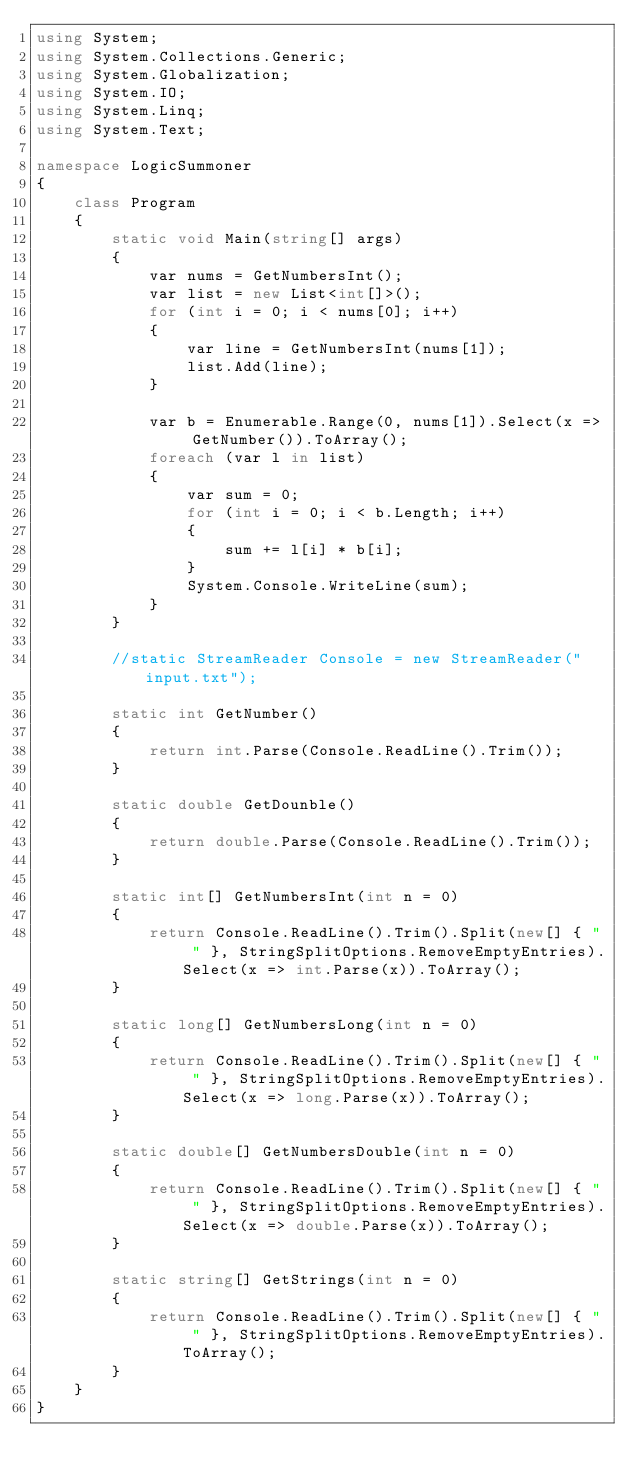Convert code to text. <code><loc_0><loc_0><loc_500><loc_500><_C#_>using System;
using System.Collections.Generic;
using System.Globalization;
using System.IO;
using System.Linq;
using System.Text;

namespace LogicSummoner
{
    class Program
    {
        static void Main(string[] args)
        {
            var nums = GetNumbersInt();
            var list = new List<int[]>();
            for (int i = 0; i < nums[0]; i++)
            {
                var line = GetNumbersInt(nums[1]);
                list.Add(line);
            }

            var b = Enumerable.Range(0, nums[1]).Select(x => GetNumber()).ToArray();
            foreach (var l in list)
            {
                var sum = 0;
                for (int i = 0; i < b.Length; i++)
                {
                    sum += l[i] * b[i];
                }
                System.Console.WriteLine(sum);
            }
        }

        //static StreamReader Console = new StreamReader("input.txt");

        static int GetNumber()
        {
            return int.Parse(Console.ReadLine().Trim());
        }

        static double GetDounble()
        {
            return double.Parse(Console.ReadLine().Trim());
        }

        static int[] GetNumbersInt(int n = 0)
        {
            return Console.ReadLine().Trim().Split(new[] { " " }, StringSplitOptions.RemoveEmptyEntries).Select(x => int.Parse(x)).ToArray();
        }

        static long[] GetNumbersLong(int n = 0)
        {
            return Console.ReadLine().Trim().Split(new[] { " " }, StringSplitOptions.RemoveEmptyEntries).Select(x => long.Parse(x)).ToArray();
        }

        static double[] GetNumbersDouble(int n = 0)
        {
            return Console.ReadLine().Trim().Split(new[] { " " }, StringSplitOptions.RemoveEmptyEntries).Select(x => double.Parse(x)).ToArray();
        }

        static string[] GetStrings(int n = 0)
        {
            return Console.ReadLine().Trim().Split(new[] { " " }, StringSplitOptions.RemoveEmptyEntries).ToArray();
        }
    }
}</code> 